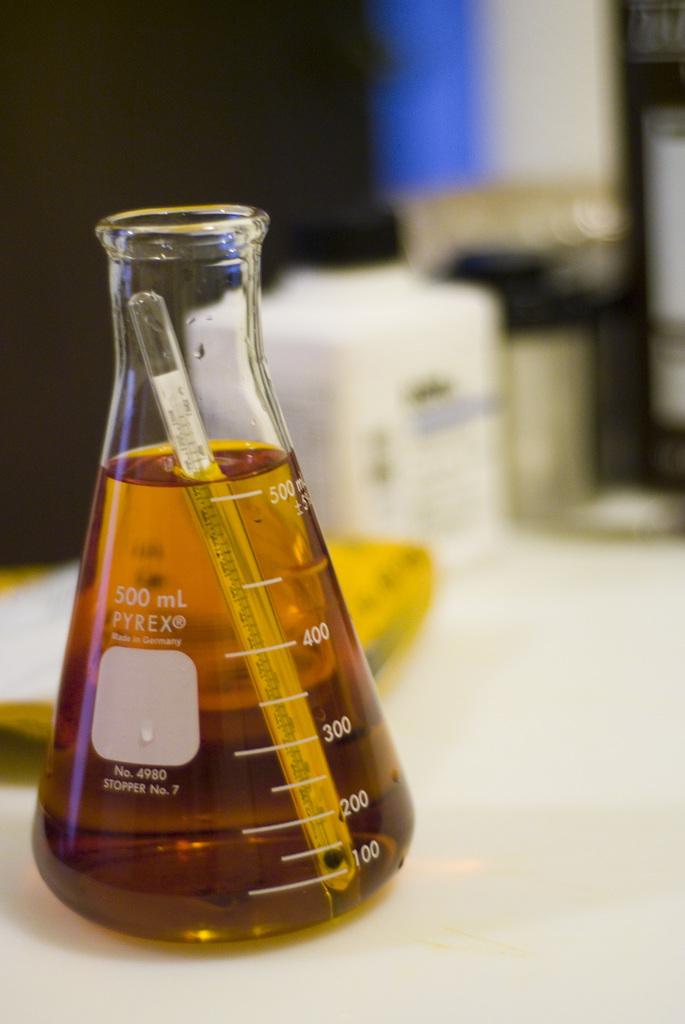What is the capacity of this glassware?
Your response must be concise. 500 ml. What no. is this beaker?
Offer a terse response. 4980. 